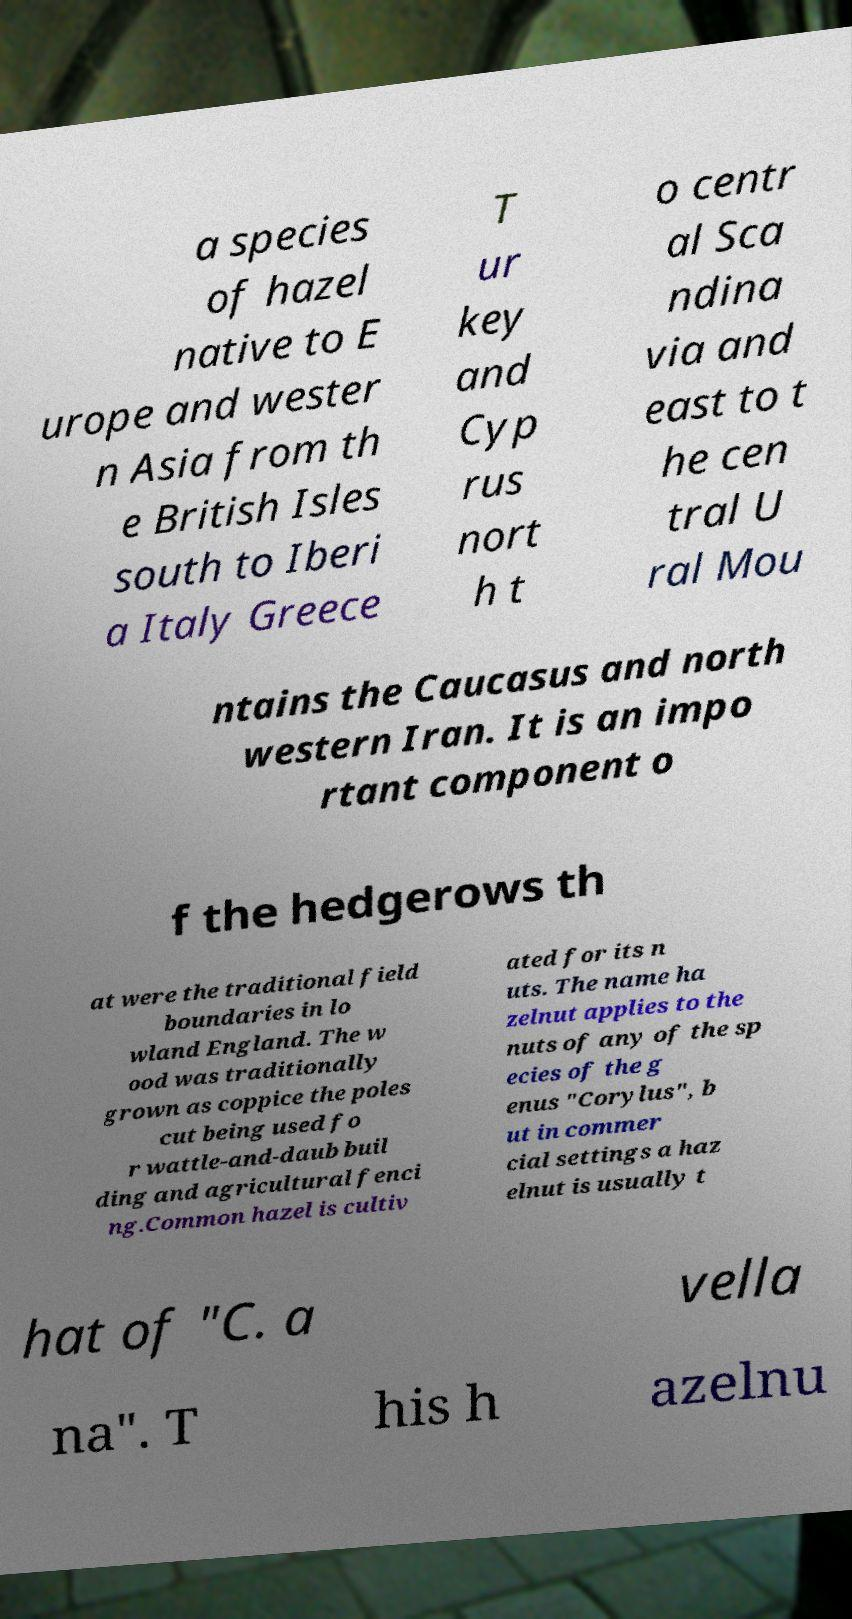Please read and relay the text visible in this image. What does it say? a species of hazel native to E urope and wester n Asia from th e British Isles south to Iberi a Italy Greece T ur key and Cyp rus nort h t o centr al Sca ndina via and east to t he cen tral U ral Mou ntains the Caucasus and north western Iran. It is an impo rtant component o f the hedgerows th at were the traditional field boundaries in lo wland England. The w ood was traditionally grown as coppice the poles cut being used fo r wattle-and-daub buil ding and agricultural fenci ng.Common hazel is cultiv ated for its n uts. The name ha zelnut applies to the nuts of any of the sp ecies of the g enus "Corylus", b ut in commer cial settings a haz elnut is usually t hat of "C. a vella na". T his h azelnu 